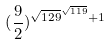<formula> <loc_0><loc_0><loc_500><loc_500>( \frac { 9 } { 2 } ) ^ { \sqrt { 1 2 9 } ^ { \sqrt { 1 1 9 } } + 1 }</formula> 